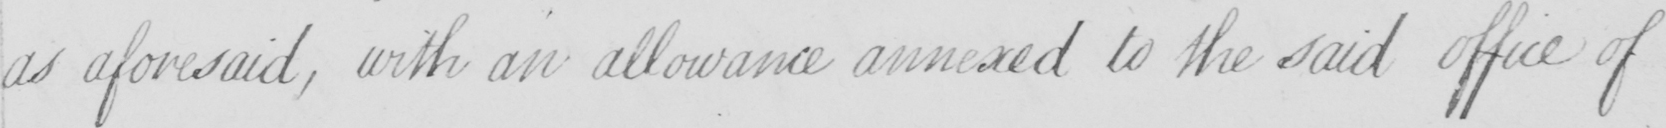What text is written in this handwritten line? as aforesaid , with an allowance annexed to the said office of 